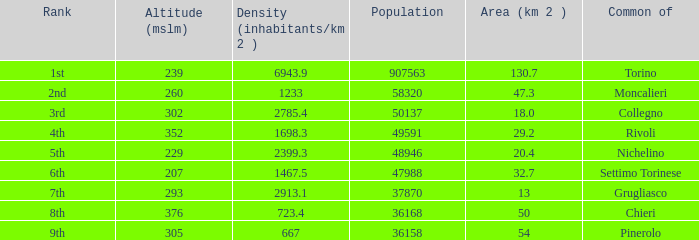What is the density of the common with an area of 20.4 km^2? 2399.3. 